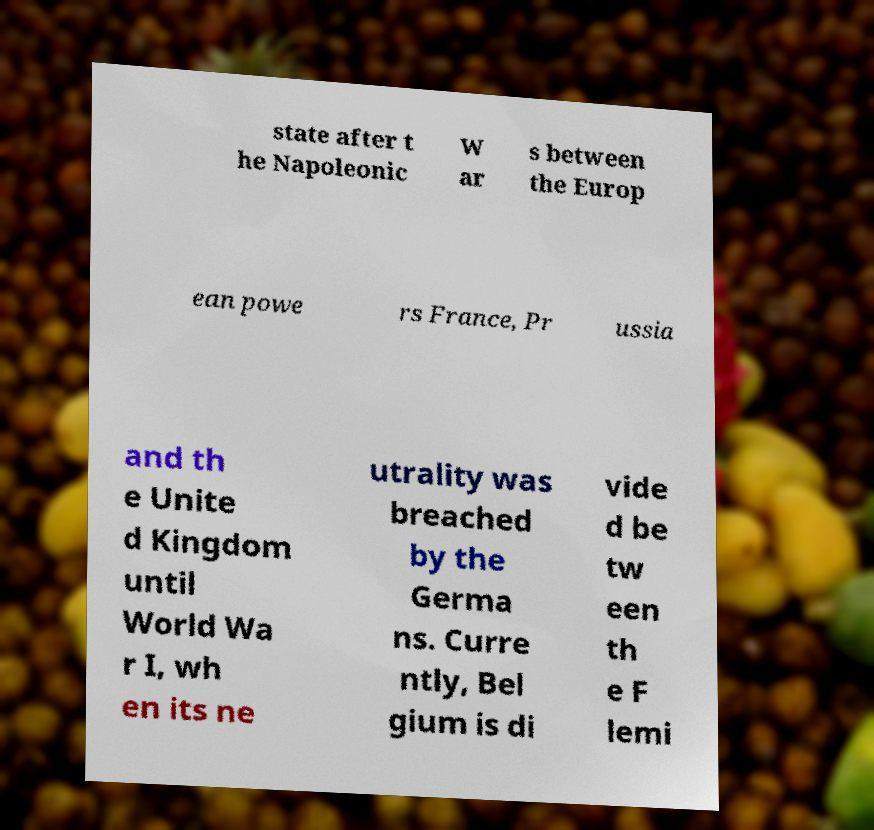Can you read and provide the text displayed in the image?This photo seems to have some interesting text. Can you extract and type it out for me? state after t he Napoleonic W ar s between the Europ ean powe rs France, Pr ussia and th e Unite d Kingdom until World Wa r I, wh en its ne utrality was breached by the Germa ns. Curre ntly, Bel gium is di vide d be tw een th e F lemi 